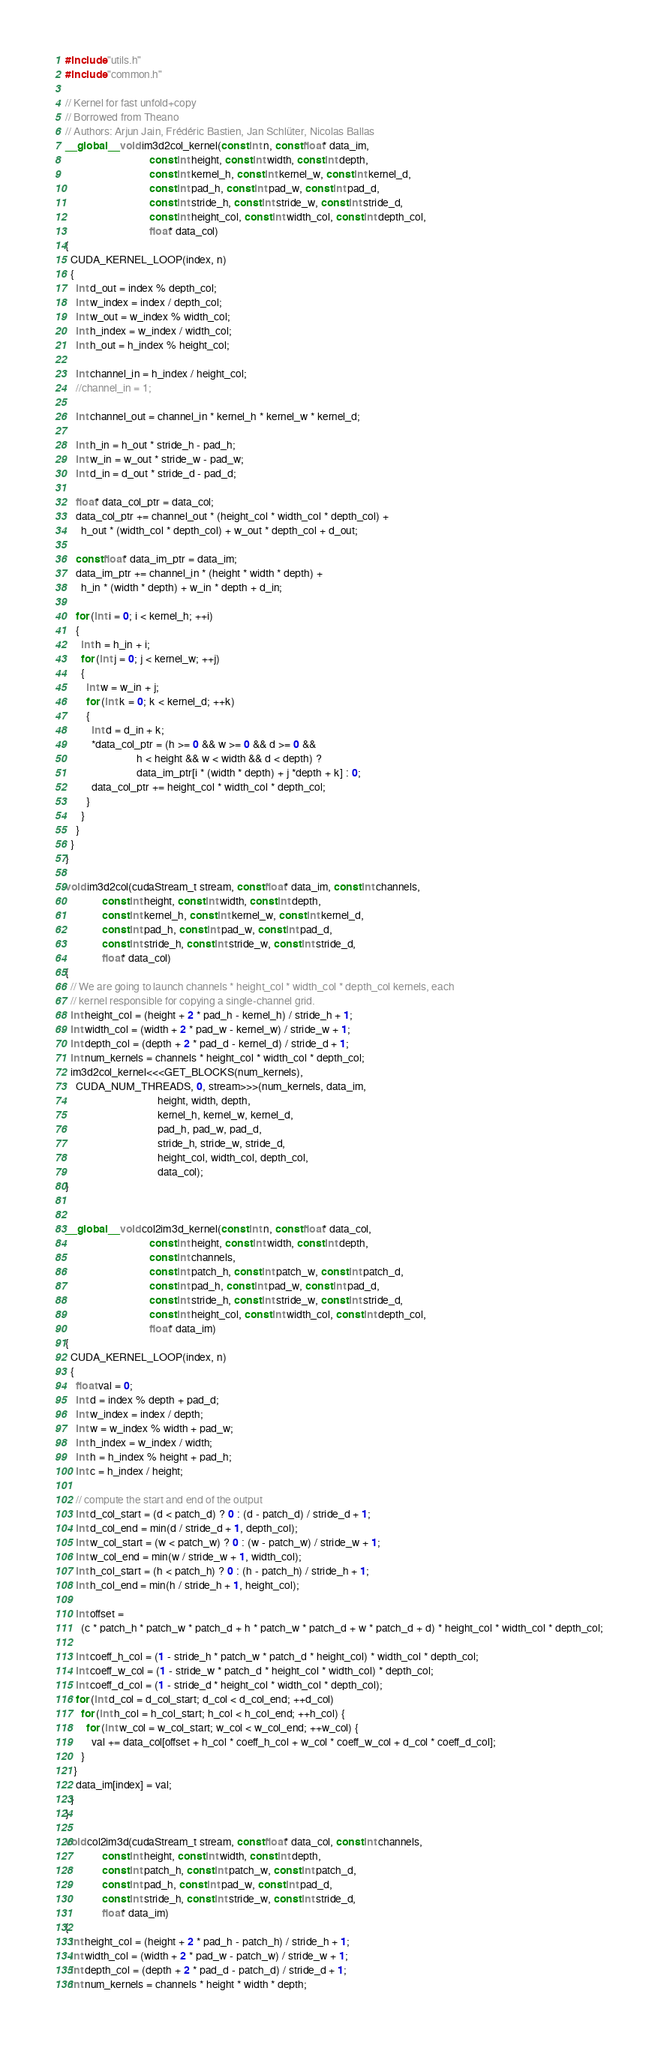<code> <loc_0><loc_0><loc_500><loc_500><_Cuda_>#include "utils.h"
#include "common.h"

// Kernel for fast unfold+copy
// Borrowed from Theano
// Authors: Arjun Jain, Frédéric Bastien, Jan Schlüter, Nicolas Ballas
__global__ void im3d2col_kernel(const int n, const float* data_im,
                                const int height, const int width, const int depth,
                                const int kernel_h, const int kernel_w, const int kernel_d,
                                const int pad_h, const int pad_w, const int pad_d,
                                const int stride_h, const int stride_w, const int stride_d,
                                const int height_col, const int width_col, const int depth_col,
                                float* data_col)
{
  CUDA_KERNEL_LOOP(index, n)
  {
    int d_out = index % depth_col;
    int w_index = index / depth_col;
    int w_out = w_index % width_col;
    int h_index = w_index / width_col;
    int h_out = h_index % height_col;

    int channel_in = h_index / height_col;
    //channel_in = 1;

    int channel_out = channel_in * kernel_h * kernel_w * kernel_d;

    int h_in = h_out * stride_h - pad_h;
    int w_in = w_out * stride_w - pad_w;
    int d_in = d_out * stride_d - pad_d;

    float* data_col_ptr = data_col;
    data_col_ptr += channel_out * (height_col * width_col * depth_col) +
      h_out * (width_col * depth_col) + w_out * depth_col + d_out;

    const float* data_im_ptr = data_im;
    data_im_ptr += channel_in * (height * width * depth) +
      h_in * (width * depth) + w_in * depth + d_in;

    for (int i = 0; i < kernel_h; ++i)
    {
      int h = h_in + i;
      for (int j = 0; j < kernel_w; ++j)
      {
        int w = w_in + j;
        for (int k = 0; k < kernel_d; ++k)
        {
          int d = d_in + k;
          *data_col_ptr = (h >= 0 && w >= 0 && d >= 0 &&
                           h < height && w < width && d < depth) ?
                           data_im_ptr[i * (width * depth) + j *depth + k] : 0;
          data_col_ptr += height_col * width_col * depth_col;
        }
      }
    }
  }
}

void im3d2col(cudaStream_t stream, const float* data_im, const int channels,
              const int height, const int width, const int depth,
              const int kernel_h, const int kernel_w, const int kernel_d,
              const int pad_h, const int pad_w, const int pad_d,
              const int stride_h, const int stride_w, const int stride_d,
              float* data_col)
{
  // We are going to launch channels * height_col * width_col * depth_col kernels, each
  // kernel responsible for copying a single-channel grid.
  int height_col = (height + 2 * pad_h - kernel_h) / stride_h + 1;
  int width_col = (width + 2 * pad_w - kernel_w) / stride_w + 1;
  int depth_col = (depth + 2 * pad_d - kernel_d) / stride_d + 1;
  int num_kernels = channels * height_col * width_col * depth_col;
  im3d2col_kernel<<<GET_BLOCKS(num_kernels),
    CUDA_NUM_THREADS, 0, stream>>>(num_kernels, data_im,
                                   height, width, depth,
                                   kernel_h, kernel_w, kernel_d,
                                   pad_h, pad_w, pad_d,
                                   stride_h, stride_w, stride_d,
                                   height_col, width_col, depth_col,
                                   data_col);
}


__global__ void col2im3d_kernel(const int n, const float* data_col,
                                const int height, const int width, const int depth,
                                const int channels,
                                const int patch_h, const int patch_w, const int patch_d,
                                const int pad_h, const int pad_w, const int pad_d,
                                const int stride_h, const int stride_w, const int stride_d,
                                const int height_col, const int width_col, const int depth_col,
                                float* data_im)
{
  CUDA_KERNEL_LOOP(index, n)
  {
    float val = 0;
    int d = index % depth + pad_d;
    int w_index = index / depth;
    int w = w_index % width + pad_w;
    int h_index = w_index / width;
    int h = h_index % height + pad_h;
    int c = h_index / height;

    // compute the start and end of the output
    int d_col_start = (d < patch_d) ? 0 : (d - patch_d) / stride_d + 1;
    int d_col_end = min(d / stride_d + 1, depth_col);
    int w_col_start = (w < patch_w) ? 0 : (w - patch_w) / stride_w + 1;
    int w_col_end = min(w / stride_w + 1, width_col);
    int h_col_start = (h < patch_h) ? 0 : (h - patch_h) / stride_h + 1;
    int h_col_end = min(h / stride_h + 1, height_col);

    int offset =
      (c * patch_h * patch_w * patch_d + h * patch_w * patch_d + w * patch_d + d) * height_col * width_col * depth_col;

    int coeff_h_col = (1 - stride_h * patch_w * patch_d * height_col) * width_col * depth_col;
    int coeff_w_col = (1 - stride_w * patch_d * height_col * width_col) * depth_col;
    int coeff_d_col = (1 - stride_d * height_col * width_col * depth_col);
    for (int d_col = d_col_start; d_col < d_col_end; ++d_col)
      for (int h_col = h_col_start; h_col < h_col_end; ++h_col) {
        for (int w_col = w_col_start; w_col < w_col_end; ++w_col) {
          val += data_col[offset + h_col * coeff_h_col + w_col * coeff_w_col + d_col * coeff_d_col];
      }
   }
    data_im[index] = val;
  }
}

void col2im3d(cudaStream_t stream, const float* data_col, const int channels,
              const int height, const int width, const int depth,
              const int patch_h, const int patch_w, const int patch_d,
              const int pad_h, const int pad_w, const int pad_d,
              const int stride_h, const int stride_w, const int stride_d,
              float* data_im)
{
  int height_col = (height + 2 * pad_h - patch_h) / stride_h + 1;
  int width_col = (width + 2 * pad_w - patch_w) / stride_w + 1;
  int depth_col = (depth + 2 * pad_d - patch_d) / stride_d + 1;
  int num_kernels = channels * height * width * depth;
</code> 